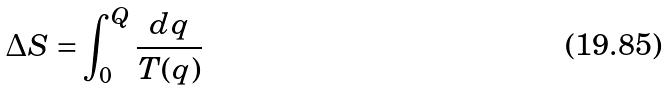Convert formula to latex. <formula><loc_0><loc_0><loc_500><loc_500>\Delta S = \int _ { 0 } ^ { Q } \frac { d q } { T ( q ) }</formula> 